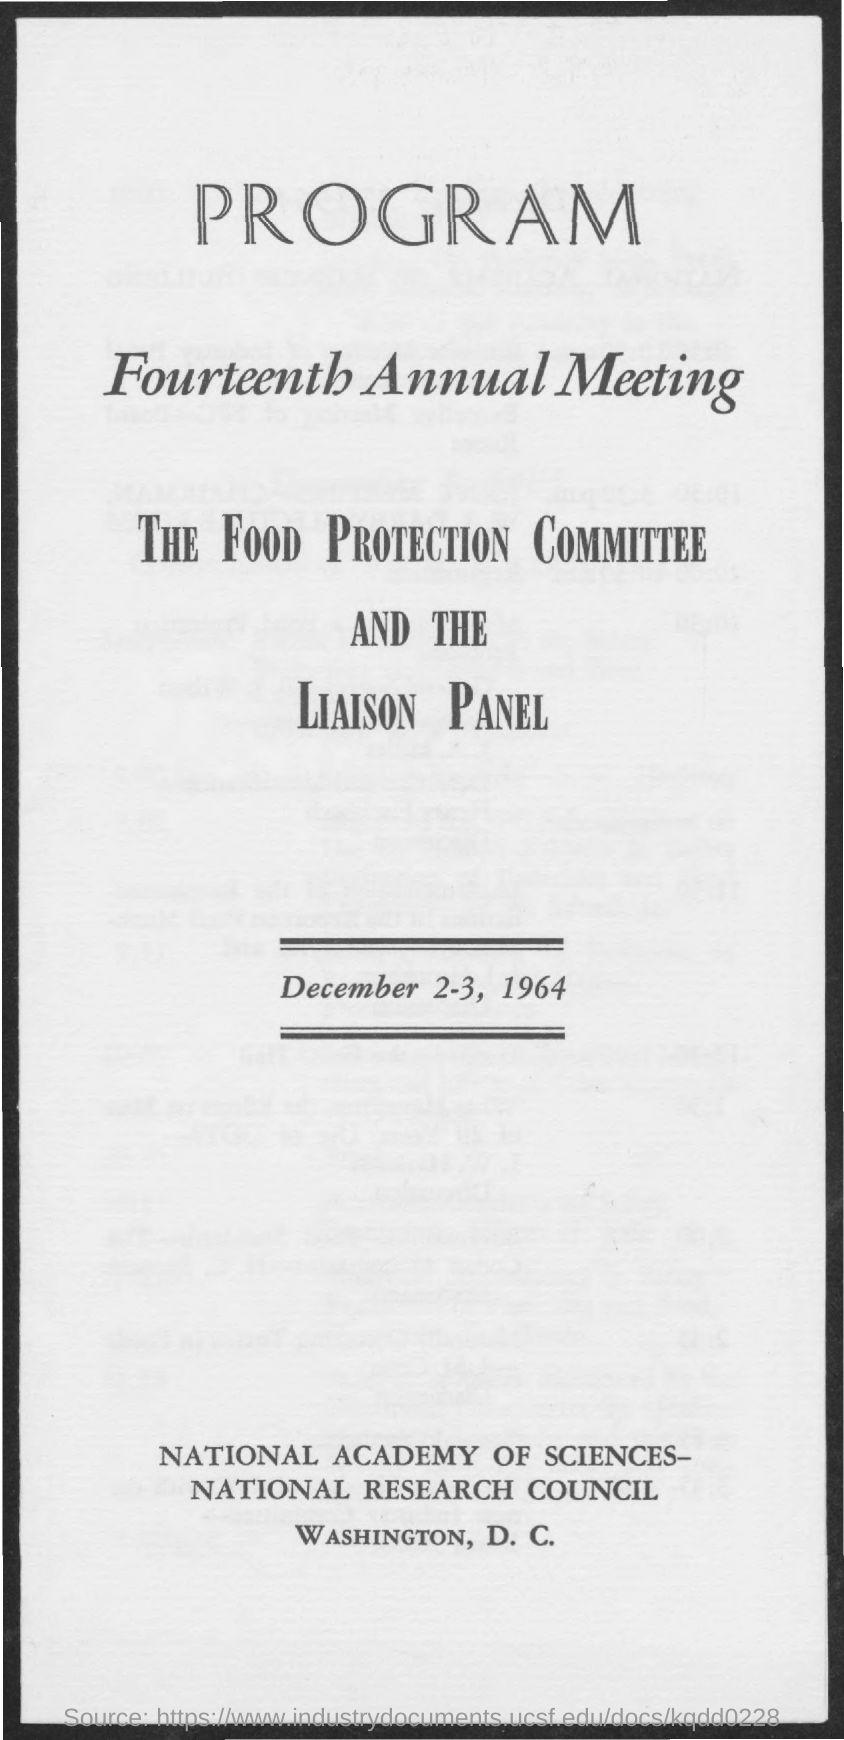What is the third title in the document?
Ensure brevity in your answer.  The food protection committee and the liaison panel. 